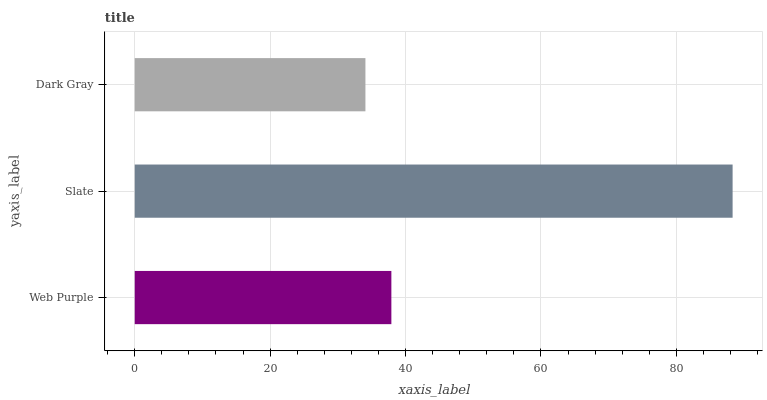Is Dark Gray the minimum?
Answer yes or no. Yes. Is Slate the maximum?
Answer yes or no. Yes. Is Slate the minimum?
Answer yes or no. No. Is Dark Gray the maximum?
Answer yes or no. No. Is Slate greater than Dark Gray?
Answer yes or no. Yes. Is Dark Gray less than Slate?
Answer yes or no. Yes. Is Dark Gray greater than Slate?
Answer yes or no. No. Is Slate less than Dark Gray?
Answer yes or no. No. Is Web Purple the high median?
Answer yes or no. Yes. Is Web Purple the low median?
Answer yes or no. Yes. Is Dark Gray the high median?
Answer yes or no. No. Is Slate the low median?
Answer yes or no. No. 